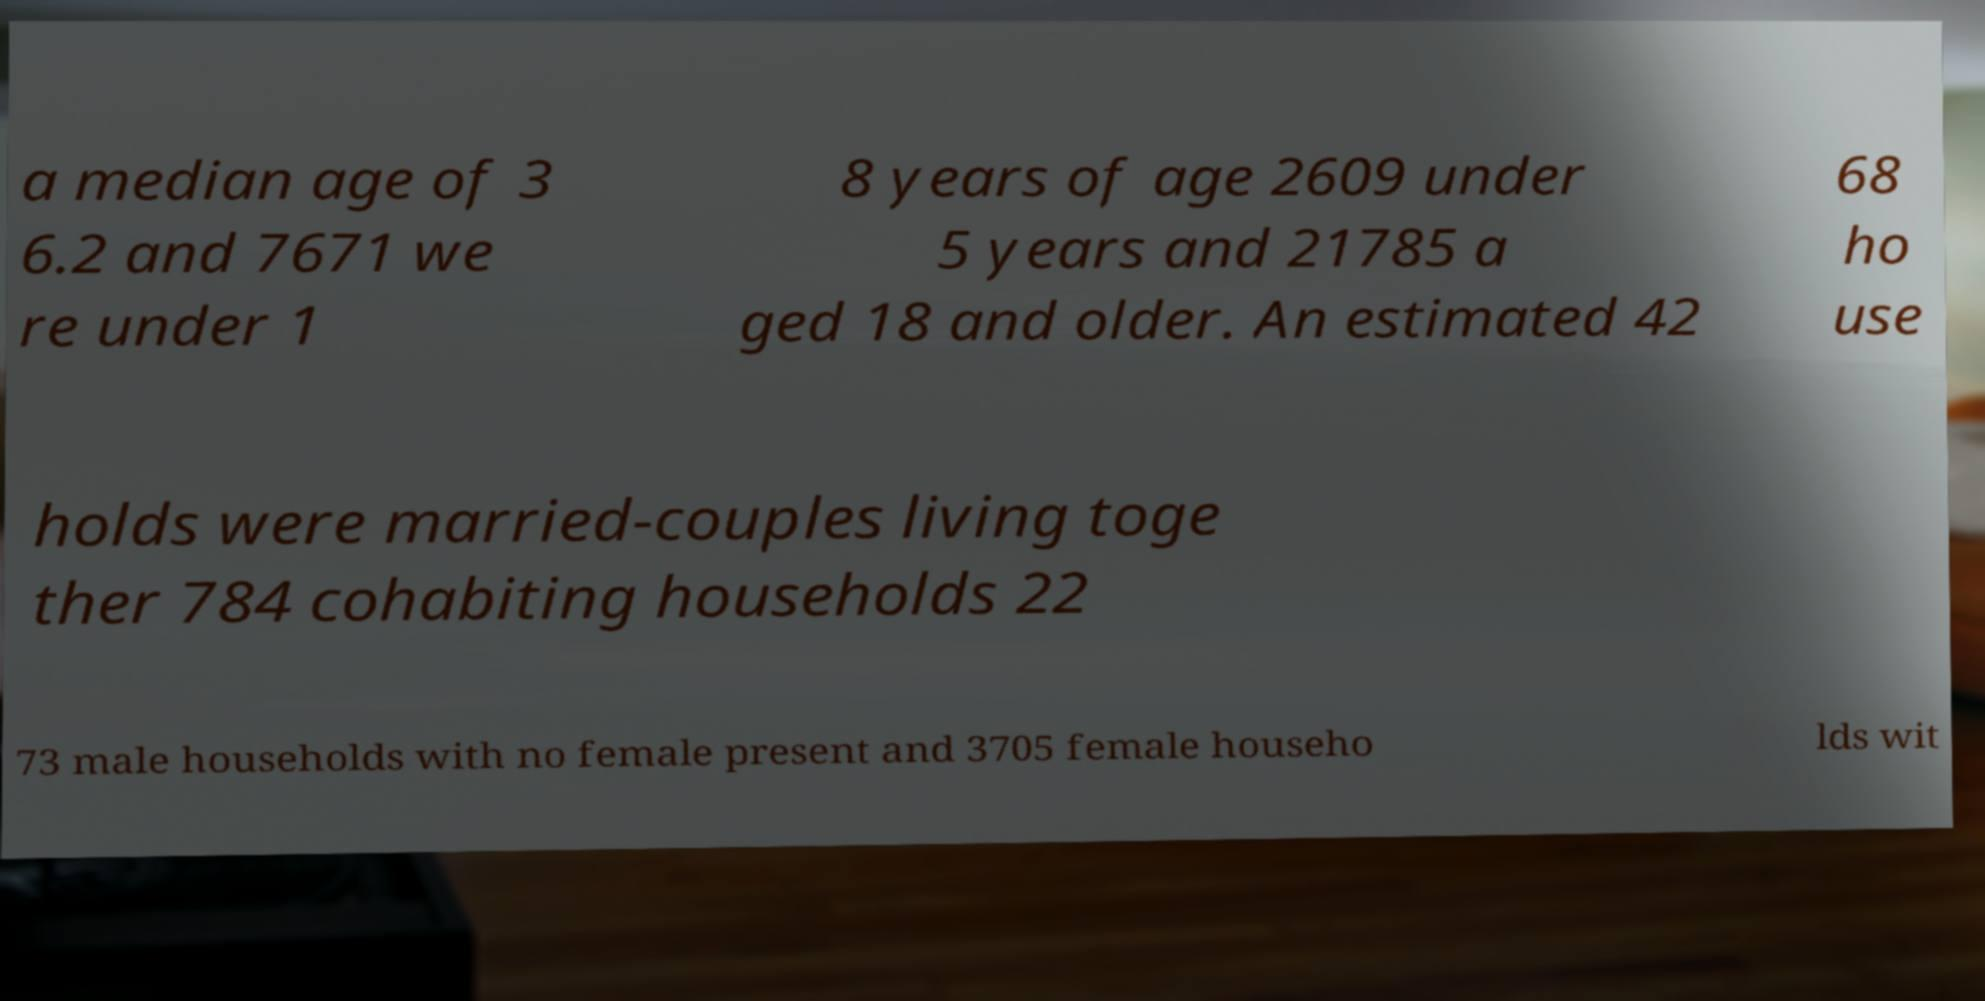What messages or text are displayed in this image? I need them in a readable, typed format. a median age of 3 6.2 and 7671 we re under 1 8 years of age 2609 under 5 years and 21785 a ged 18 and older. An estimated 42 68 ho use holds were married-couples living toge ther 784 cohabiting households 22 73 male households with no female present and 3705 female househo lds wit 